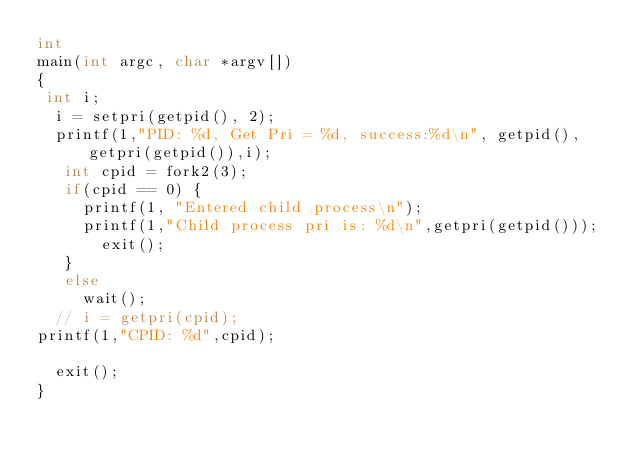Convert code to text. <code><loc_0><loc_0><loc_500><loc_500><_C_>int
main(int argc, char *argv[])
{
 int i;
  i = setpri(getpid(), 2);
  printf(1,"PID: %d, Get Pri = %d, success:%d\n", getpid(), getpri(getpid()),i);
   int cpid = fork2(3);
   if(cpid == 0) {
	   printf(1, "Entered child process\n");
	   printf(1,"Child process pri is: %d\n",getpri(getpid()));
   	   exit();
   }
   else
	   wait();
  // i = getpri(cpid);
printf(1,"CPID: %d",cpid);
  
  exit();
}
</code> 